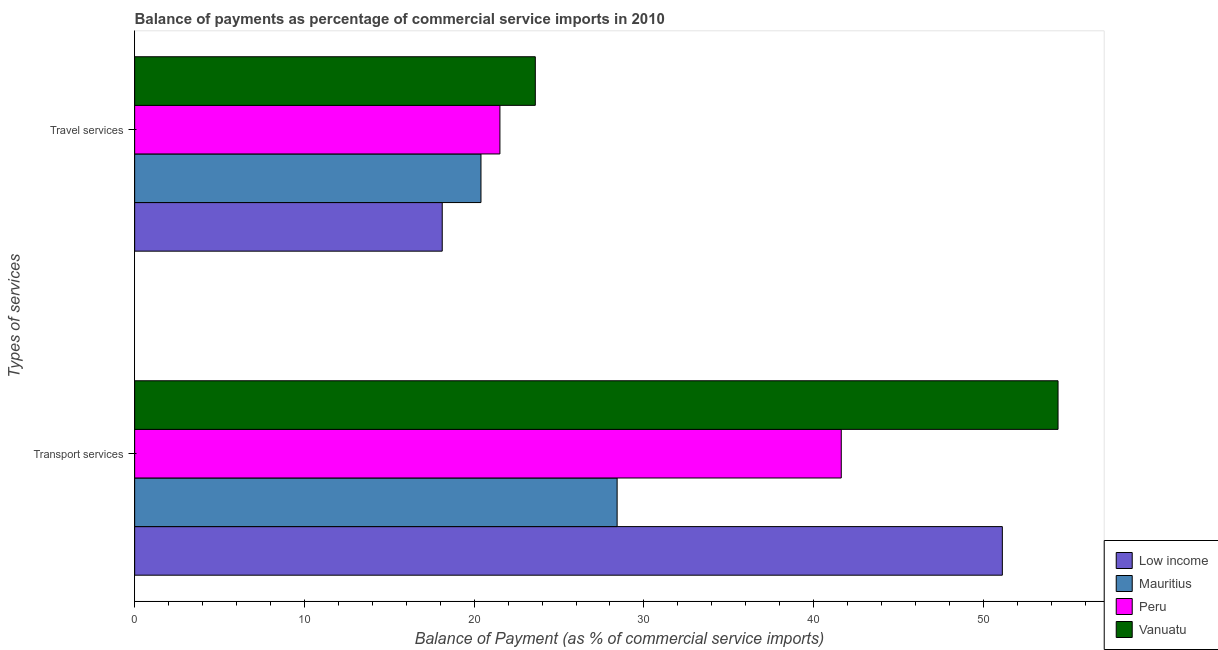How many groups of bars are there?
Offer a very short reply. 2. Are the number of bars on each tick of the Y-axis equal?
Ensure brevity in your answer.  Yes. What is the label of the 1st group of bars from the top?
Ensure brevity in your answer.  Travel services. What is the balance of payments of travel services in Vanuatu?
Your answer should be very brief. 23.6. Across all countries, what is the maximum balance of payments of travel services?
Keep it short and to the point. 23.6. Across all countries, what is the minimum balance of payments of transport services?
Offer a terse response. 28.42. In which country was the balance of payments of travel services maximum?
Keep it short and to the point. Vanuatu. In which country was the balance of payments of transport services minimum?
Offer a terse response. Mauritius. What is the total balance of payments of transport services in the graph?
Your response must be concise. 175.56. What is the difference between the balance of payments of transport services in Vanuatu and that in Low income?
Your answer should be compact. 3.28. What is the difference between the balance of payments of travel services in Mauritius and the balance of payments of transport services in Low income?
Provide a succinct answer. -30.71. What is the average balance of payments of transport services per country?
Ensure brevity in your answer.  43.89. What is the difference between the balance of payments of transport services and balance of payments of travel services in Low income?
Your answer should be very brief. 33. In how many countries, is the balance of payments of transport services greater than 6 %?
Your answer should be compact. 4. What is the ratio of the balance of payments of travel services in Low income to that in Mauritius?
Offer a terse response. 0.89. Is the balance of payments of transport services in Vanuatu less than that in Peru?
Provide a succinct answer. No. What does the 2nd bar from the top in Travel services represents?
Provide a short and direct response. Peru. What does the 2nd bar from the bottom in Travel services represents?
Your answer should be compact. Mauritius. How many bars are there?
Give a very brief answer. 8. Are all the bars in the graph horizontal?
Ensure brevity in your answer.  Yes. How many countries are there in the graph?
Give a very brief answer. 4. Does the graph contain any zero values?
Keep it short and to the point. No. Does the graph contain grids?
Ensure brevity in your answer.  No. How many legend labels are there?
Your answer should be compact. 4. How are the legend labels stacked?
Keep it short and to the point. Vertical. What is the title of the graph?
Provide a succinct answer. Balance of payments as percentage of commercial service imports in 2010. What is the label or title of the X-axis?
Offer a very short reply. Balance of Payment (as % of commercial service imports). What is the label or title of the Y-axis?
Offer a terse response. Types of services. What is the Balance of Payment (as % of commercial service imports) of Low income in Transport services?
Your answer should be very brief. 51.12. What is the Balance of Payment (as % of commercial service imports) of Mauritius in Transport services?
Your response must be concise. 28.42. What is the Balance of Payment (as % of commercial service imports) of Peru in Transport services?
Offer a terse response. 41.63. What is the Balance of Payment (as % of commercial service imports) of Vanuatu in Transport services?
Offer a terse response. 54.4. What is the Balance of Payment (as % of commercial service imports) in Low income in Travel services?
Your response must be concise. 18.12. What is the Balance of Payment (as % of commercial service imports) of Mauritius in Travel services?
Offer a terse response. 20.4. What is the Balance of Payment (as % of commercial service imports) of Peru in Travel services?
Offer a very short reply. 21.52. What is the Balance of Payment (as % of commercial service imports) of Vanuatu in Travel services?
Give a very brief answer. 23.6. Across all Types of services, what is the maximum Balance of Payment (as % of commercial service imports) of Low income?
Provide a short and direct response. 51.12. Across all Types of services, what is the maximum Balance of Payment (as % of commercial service imports) of Mauritius?
Keep it short and to the point. 28.42. Across all Types of services, what is the maximum Balance of Payment (as % of commercial service imports) of Peru?
Your answer should be very brief. 41.63. Across all Types of services, what is the maximum Balance of Payment (as % of commercial service imports) of Vanuatu?
Give a very brief answer. 54.4. Across all Types of services, what is the minimum Balance of Payment (as % of commercial service imports) in Low income?
Make the answer very short. 18.12. Across all Types of services, what is the minimum Balance of Payment (as % of commercial service imports) of Mauritius?
Your answer should be very brief. 20.4. Across all Types of services, what is the minimum Balance of Payment (as % of commercial service imports) of Peru?
Your answer should be very brief. 21.52. Across all Types of services, what is the minimum Balance of Payment (as % of commercial service imports) of Vanuatu?
Keep it short and to the point. 23.6. What is the total Balance of Payment (as % of commercial service imports) of Low income in the graph?
Give a very brief answer. 69.24. What is the total Balance of Payment (as % of commercial service imports) of Mauritius in the graph?
Keep it short and to the point. 48.82. What is the total Balance of Payment (as % of commercial service imports) of Peru in the graph?
Give a very brief answer. 63.15. What is the difference between the Balance of Payment (as % of commercial service imports) of Low income in Transport services and that in Travel services?
Your answer should be compact. 33. What is the difference between the Balance of Payment (as % of commercial service imports) in Mauritius in Transport services and that in Travel services?
Offer a very short reply. 8.02. What is the difference between the Balance of Payment (as % of commercial service imports) of Peru in Transport services and that in Travel services?
Ensure brevity in your answer.  20.11. What is the difference between the Balance of Payment (as % of commercial service imports) of Vanuatu in Transport services and that in Travel services?
Provide a short and direct response. 30.79. What is the difference between the Balance of Payment (as % of commercial service imports) of Low income in Transport services and the Balance of Payment (as % of commercial service imports) of Mauritius in Travel services?
Provide a succinct answer. 30.71. What is the difference between the Balance of Payment (as % of commercial service imports) in Low income in Transport services and the Balance of Payment (as % of commercial service imports) in Peru in Travel services?
Make the answer very short. 29.6. What is the difference between the Balance of Payment (as % of commercial service imports) of Low income in Transport services and the Balance of Payment (as % of commercial service imports) of Vanuatu in Travel services?
Make the answer very short. 27.51. What is the difference between the Balance of Payment (as % of commercial service imports) of Mauritius in Transport services and the Balance of Payment (as % of commercial service imports) of Peru in Travel services?
Provide a short and direct response. 6.9. What is the difference between the Balance of Payment (as % of commercial service imports) of Mauritius in Transport services and the Balance of Payment (as % of commercial service imports) of Vanuatu in Travel services?
Keep it short and to the point. 4.82. What is the difference between the Balance of Payment (as % of commercial service imports) in Peru in Transport services and the Balance of Payment (as % of commercial service imports) in Vanuatu in Travel services?
Your answer should be very brief. 18.02. What is the average Balance of Payment (as % of commercial service imports) in Low income per Types of services?
Keep it short and to the point. 34.62. What is the average Balance of Payment (as % of commercial service imports) of Mauritius per Types of services?
Keep it short and to the point. 24.41. What is the average Balance of Payment (as % of commercial service imports) in Peru per Types of services?
Your response must be concise. 31.57. What is the difference between the Balance of Payment (as % of commercial service imports) of Low income and Balance of Payment (as % of commercial service imports) of Mauritius in Transport services?
Make the answer very short. 22.69. What is the difference between the Balance of Payment (as % of commercial service imports) in Low income and Balance of Payment (as % of commercial service imports) in Peru in Transport services?
Your answer should be compact. 9.49. What is the difference between the Balance of Payment (as % of commercial service imports) in Low income and Balance of Payment (as % of commercial service imports) in Vanuatu in Transport services?
Your answer should be compact. -3.28. What is the difference between the Balance of Payment (as % of commercial service imports) of Mauritius and Balance of Payment (as % of commercial service imports) of Peru in Transport services?
Provide a succinct answer. -13.2. What is the difference between the Balance of Payment (as % of commercial service imports) in Mauritius and Balance of Payment (as % of commercial service imports) in Vanuatu in Transport services?
Your answer should be compact. -25.97. What is the difference between the Balance of Payment (as % of commercial service imports) of Peru and Balance of Payment (as % of commercial service imports) of Vanuatu in Transport services?
Ensure brevity in your answer.  -12.77. What is the difference between the Balance of Payment (as % of commercial service imports) in Low income and Balance of Payment (as % of commercial service imports) in Mauritius in Travel services?
Your response must be concise. -2.28. What is the difference between the Balance of Payment (as % of commercial service imports) of Low income and Balance of Payment (as % of commercial service imports) of Peru in Travel services?
Keep it short and to the point. -3.4. What is the difference between the Balance of Payment (as % of commercial service imports) in Low income and Balance of Payment (as % of commercial service imports) in Vanuatu in Travel services?
Keep it short and to the point. -5.48. What is the difference between the Balance of Payment (as % of commercial service imports) of Mauritius and Balance of Payment (as % of commercial service imports) of Peru in Travel services?
Provide a short and direct response. -1.12. What is the difference between the Balance of Payment (as % of commercial service imports) in Mauritius and Balance of Payment (as % of commercial service imports) in Vanuatu in Travel services?
Offer a terse response. -3.2. What is the difference between the Balance of Payment (as % of commercial service imports) of Peru and Balance of Payment (as % of commercial service imports) of Vanuatu in Travel services?
Keep it short and to the point. -2.08. What is the ratio of the Balance of Payment (as % of commercial service imports) in Low income in Transport services to that in Travel services?
Give a very brief answer. 2.82. What is the ratio of the Balance of Payment (as % of commercial service imports) of Mauritius in Transport services to that in Travel services?
Your answer should be compact. 1.39. What is the ratio of the Balance of Payment (as % of commercial service imports) in Peru in Transport services to that in Travel services?
Make the answer very short. 1.93. What is the ratio of the Balance of Payment (as % of commercial service imports) of Vanuatu in Transport services to that in Travel services?
Provide a succinct answer. 2.3. What is the difference between the highest and the second highest Balance of Payment (as % of commercial service imports) of Low income?
Ensure brevity in your answer.  33. What is the difference between the highest and the second highest Balance of Payment (as % of commercial service imports) in Mauritius?
Your response must be concise. 8.02. What is the difference between the highest and the second highest Balance of Payment (as % of commercial service imports) in Peru?
Keep it short and to the point. 20.11. What is the difference between the highest and the second highest Balance of Payment (as % of commercial service imports) in Vanuatu?
Ensure brevity in your answer.  30.79. What is the difference between the highest and the lowest Balance of Payment (as % of commercial service imports) in Low income?
Offer a very short reply. 33. What is the difference between the highest and the lowest Balance of Payment (as % of commercial service imports) in Mauritius?
Your response must be concise. 8.02. What is the difference between the highest and the lowest Balance of Payment (as % of commercial service imports) of Peru?
Keep it short and to the point. 20.11. What is the difference between the highest and the lowest Balance of Payment (as % of commercial service imports) in Vanuatu?
Offer a terse response. 30.79. 